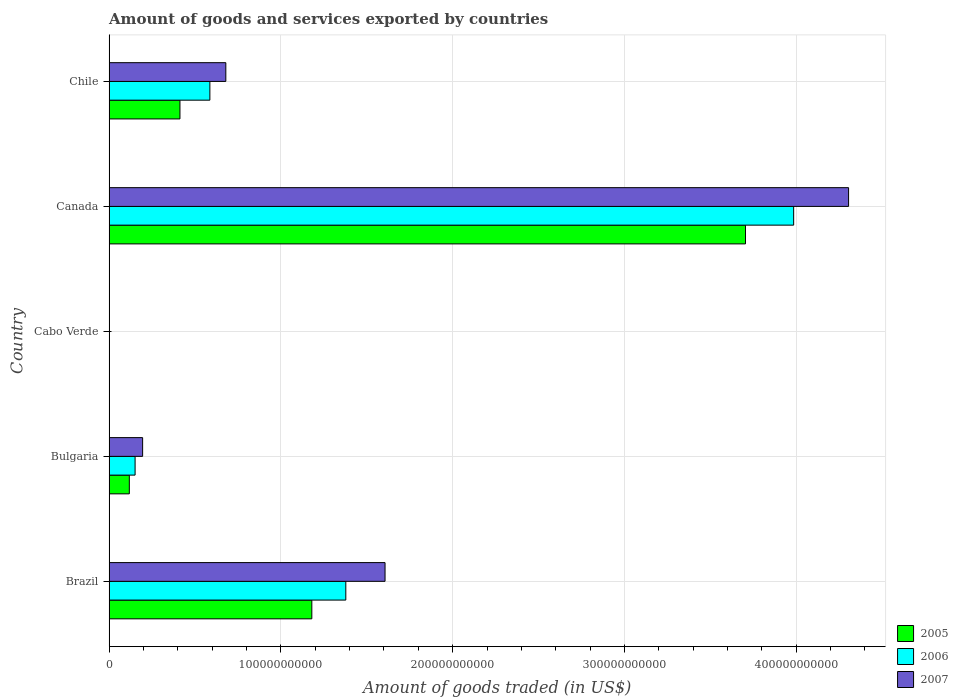How many different coloured bars are there?
Ensure brevity in your answer.  3. Are the number of bars per tick equal to the number of legend labels?
Offer a very short reply. Yes. How many bars are there on the 4th tick from the top?
Your answer should be compact. 3. How many bars are there on the 4th tick from the bottom?
Your answer should be very brief. 3. In how many cases, is the number of bars for a given country not equal to the number of legend labels?
Keep it short and to the point. 0. What is the total amount of goods and services exported in 2005 in Chile?
Keep it short and to the point. 4.13e+1. Across all countries, what is the maximum total amount of goods and services exported in 2007?
Ensure brevity in your answer.  4.30e+11. Across all countries, what is the minimum total amount of goods and services exported in 2005?
Provide a short and direct response. 7.71e+07. In which country was the total amount of goods and services exported in 2007 maximum?
Provide a short and direct response. Canada. In which country was the total amount of goods and services exported in 2006 minimum?
Provide a short and direct response. Cabo Verde. What is the total total amount of goods and services exported in 2005 in the graph?
Provide a succinct answer. 5.42e+11. What is the difference between the total amount of goods and services exported in 2006 in Bulgaria and that in Chile?
Make the answer very short. -4.35e+1. What is the difference between the total amount of goods and services exported in 2005 in Cabo Verde and the total amount of goods and services exported in 2007 in Chile?
Offer a terse response. -6.79e+1. What is the average total amount of goods and services exported in 2005 per country?
Provide a short and direct response. 1.08e+11. What is the difference between the total amount of goods and services exported in 2005 and total amount of goods and services exported in 2006 in Bulgaria?
Provide a succinct answer. -3.36e+09. What is the ratio of the total amount of goods and services exported in 2005 in Cabo Verde to that in Canada?
Your answer should be compact. 0. Is the total amount of goods and services exported in 2007 in Bulgaria less than that in Chile?
Make the answer very short. Yes. What is the difference between the highest and the second highest total amount of goods and services exported in 2006?
Provide a succinct answer. 2.61e+11. What is the difference between the highest and the lowest total amount of goods and services exported in 2006?
Provide a short and direct response. 3.98e+11. What does the 2nd bar from the top in Canada represents?
Your answer should be compact. 2006. Is it the case that in every country, the sum of the total amount of goods and services exported in 2007 and total amount of goods and services exported in 2005 is greater than the total amount of goods and services exported in 2006?
Provide a short and direct response. Yes. How many bars are there?
Offer a very short reply. 15. How many countries are there in the graph?
Your answer should be very brief. 5. What is the difference between two consecutive major ticks on the X-axis?
Provide a short and direct response. 1.00e+11. How are the legend labels stacked?
Provide a succinct answer. Vertical. What is the title of the graph?
Provide a short and direct response. Amount of goods and services exported by countries. What is the label or title of the X-axis?
Offer a very short reply. Amount of goods traded (in US$). What is the Amount of goods traded (in US$) in 2005 in Brazil?
Give a very brief answer. 1.18e+11. What is the Amount of goods traded (in US$) of 2006 in Brazil?
Keep it short and to the point. 1.38e+11. What is the Amount of goods traded (in US$) in 2007 in Brazil?
Your response must be concise. 1.61e+11. What is the Amount of goods traded (in US$) of 2005 in Bulgaria?
Offer a terse response. 1.18e+1. What is the Amount of goods traded (in US$) in 2006 in Bulgaria?
Your response must be concise. 1.52e+1. What is the Amount of goods traded (in US$) of 2007 in Bulgaria?
Keep it short and to the point. 1.95e+1. What is the Amount of goods traded (in US$) of 2005 in Cabo Verde?
Offer a very short reply. 7.71e+07. What is the Amount of goods traded (in US$) in 2006 in Cabo Verde?
Provide a short and direct response. 8.58e+07. What is the Amount of goods traded (in US$) in 2007 in Cabo Verde?
Offer a terse response. 6.97e+07. What is the Amount of goods traded (in US$) of 2005 in Canada?
Your response must be concise. 3.70e+11. What is the Amount of goods traded (in US$) in 2006 in Canada?
Your answer should be very brief. 3.99e+11. What is the Amount of goods traded (in US$) of 2007 in Canada?
Your answer should be very brief. 4.30e+11. What is the Amount of goods traded (in US$) of 2005 in Chile?
Give a very brief answer. 4.13e+1. What is the Amount of goods traded (in US$) in 2006 in Chile?
Give a very brief answer. 5.87e+1. What is the Amount of goods traded (in US$) of 2007 in Chile?
Provide a short and direct response. 6.80e+1. Across all countries, what is the maximum Amount of goods traded (in US$) in 2005?
Offer a terse response. 3.70e+11. Across all countries, what is the maximum Amount of goods traded (in US$) of 2006?
Provide a short and direct response. 3.99e+11. Across all countries, what is the maximum Amount of goods traded (in US$) of 2007?
Offer a very short reply. 4.30e+11. Across all countries, what is the minimum Amount of goods traded (in US$) of 2005?
Keep it short and to the point. 7.71e+07. Across all countries, what is the minimum Amount of goods traded (in US$) in 2006?
Offer a very short reply. 8.58e+07. Across all countries, what is the minimum Amount of goods traded (in US$) in 2007?
Keep it short and to the point. 6.97e+07. What is the total Amount of goods traded (in US$) of 2005 in the graph?
Make the answer very short. 5.42e+11. What is the total Amount of goods traded (in US$) of 2006 in the graph?
Provide a short and direct response. 6.10e+11. What is the total Amount of goods traded (in US$) in 2007 in the graph?
Make the answer very short. 6.79e+11. What is the difference between the Amount of goods traded (in US$) in 2005 in Brazil and that in Bulgaria?
Make the answer very short. 1.06e+11. What is the difference between the Amount of goods traded (in US$) in 2006 in Brazil and that in Bulgaria?
Provide a succinct answer. 1.23e+11. What is the difference between the Amount of goods traded (in US$) in 2007 in Brazil and that in Bulgaria?
Provide a short and direct response. 1.41e+11. What is the difference between the Amount of goods traded (in US$) in 2005 in Brazil and that in Cabo Verde?
Keep it short and to the point. 1.18e+11. What is the difference between the Amount of goods traded (in US$) of 2006 in Brazil and that in Cabo Verde?
Your answer should be compact. 1.38e+11. What is the difference between the Amount of goods traded (in US$) in 2007 in Brazil and that in Cabo Verde?
Keep it short and to the point. 1.61e+11. What is the difference between the Amount of goods traded (in US$) in 2005 in Brazil and that in Canada?
Your response must be concise. -2.52e+11. What is the difference between the Amount of goods traded (in US$) of 2006 in Brazil and that in Canada?
Provide a succinct answer. -2.61e+11. What is the difference between the Amount of goods traded (in US$) of 2007 in Brazil and that in Canada?
Provide a succinct answer. -2.70e+11. What is the difference between the Amount of goods traded (in US$) in 2005 in Brazil and that in Chile?
Provide a succinct answer. 7.68e+1. What is the difference between the Amount of goods traded (in US$) in 2006 in Brazil and that in Chile?
Your answer should be compact. 7.91e+1. What is the difference between the Amount of goods traded (in US$) in 2007 in Brazil and that in Chile?
Make the answer very short. 9.27e+1. What is the difference between the Amount of goods traded (in US$) in 2005 in Bulgaria and that in Cabo Verde?
Provide a short and direct response. 1.17e+1. What is the difference between the Amount of goods traded (in US$) of 2006 in Bulgaria and that in Cabo Verde?
Your answer should be compact. 1.51e+1. What is the difference between the Amount of goods traded (in US$) of 2007 in Bulgaria and that in Cabo Verde?
Give a very brief answer. 1.95e+1. What is the difference between the Amount of goods traded (in US$) in 2005 in Bulgaria and that in Canada?
Offer a very short reply. -3.59e+11. What is the difference between the Amount of goods traded (in US$) in 2006 in Bulgaria and that in Canada?
Provide a short and direct response. -3.83e+11. What is the difference between the Amount of goods traded (in US$) in 2007 in Bulgaria and that in Canada?
Offer a very short reply. -4.11e+11. What is the difference between the Amount of goods traded (in US$) of 2005 in Bulgaria and that in Chile?
Provide a short and direct response. -2.95e+1. What is the difference between the Amount of goods traded (in US$) in 2006 in Bulgaria and that in Chile?
Your answer should be compact. -4.35e+1. What is the difference between the Amount of goods traded (in US$) of 2007 in Bulgaria and that in Chile?
Give a very brief answer. -4.84e+1. What is the difference between the Amount of goods traded (in US$) in 2005 in Cabo Verde and that in Canada?
Keep it short and to the point. -3.70e+11. What is the difference between the Amount of goods traded (in US$) in 2006 in Cabo Verde and that in Canada?
Provide a short and direct response. -3.98e+11. What is the difference between the Amount of goods traded (in US$) in 2007 in Cabo Verde and that in Canada?
Provide a succinct answer. -4.30e+11. What is the difference between the Amount of goods traded (in US$) in 2005 in Cabo Verde and that in Chile?
Give a very brief answer. -4.12e+1. What is the difference between the Amount of goods traded (in US$) of 2006 in Cabo Verde and that in Chile?
Offer a terse response. -5.86e+1. What is the difference between the Amount of goods traded (in US$) in 2007 in Cabo Verde and that in Chile?
Make the answer very short. -6.79e+1. What is the difference between the Amount of goods traded (in US$) of 2005 in Canada and that in Chile?
Provide a succinct answer. 3.29e+11. What is the difference between the Amount of goods traded (in US$) of 2006 in Canada and that in Chile?
Your answer should be very brief. 3.40e+11. What is the difference between the Amount of goods traded (in US$) in 2007 in Canada and that in Chile?
Your answer should be compact. 3.63e+11. What is the difference between the Amount of goods traded (in US$) in 2005 in Brazil and the Amount of goods traded (in US$) in 2006 in Bulgaria?
Provide a short and direct response. 1.03e+11. What is the difference between the Amount of goods traded (in US$) of 2005 in Brazil and the Amount of goods traded (in US$) of 2007 in Bulgaria?
Keep it short and to the point. 9.85e+1. What is the difference between the Amount of goods traded (in US$) of 2006 in Brazil and the Amount of goods traded (in US$) of 2007 in Bulgaria?
Your response must be concise. 1.18e+11. What is the difference between the Amount of goods traded (in US$) in 2005 in Brazil and the Amount of goods traded (in US$) in 2006 in Cabo Verde?
Ensure brevity in your answer.  1.18e+11. What is the difference between the Amount of goods traded (in US$) of 2005 in Brazil and the Amount of goods traded (in US$) of 2007 in Cabo Verde?
Provide a short and direct response. 1.18e+11. What is the difference between the Amount of goods traded (in US$) in 2006 in Brazil and the Amount of goods traded (in US$) in 2007 in Cabo Verde?
Give a very brief answer. 1.38e+11. What is the difference between the Amount of goods traded (in US$) in 2005 in Brazil and the Amount of goods traded (in US$) in 2006 in Canada?
Give a very brief answer. -2.80e+11. What is the difference between the Amount of goods traded (in US$) in 2005 in Brazil and the Amount of goods traded (in US$) in 2007 in Canada?
Provide a succinct answer. -3.12e+11. What is the difference between the Amount of goods traded (in US$) in 2006 in Brazil and the Amount of goods traded (in US$) in 2007 in Canada?
Your answer should be very brief. -2.93e+11. What is the difference between the Amount of goods traded (in US$) of 2005 in Brazil and the Amount of goods traded (in US$) of 2006 in Chile?
Your response must be concise. 5.94e+1. What is the difference between the Amount of goods traded (in US$) of 2005 in Brazil and the Amount of goods traded (in US$) of 2007 in Chile?
Give a very brief answer. 5.01e+1. What is the difference between the Amount of goods traded (in US$) in 2006 in Brazil and the Amount of goods traded (in US$) in 2007 in Chile?
Offer a very short reply. 6.98e+1. What is the difference between the Amount of goods traded (in US$) of 2005 in Bulgaria and the Amount of goods traded (in US$) of 2006 in Cabo Verde?
Provide a short and direct response. 1.17e+1. What is the difference between the Amount of goods traded (in US$) of 2005 in Bulgaria and the Amount of goods traded (in US$) of 2007 in Cabo Verde?
Your answer should be compact. 1.17e+1. What is the difference between the Amount of goods traded (in US$) of 2006 in Bulgaria and the Amount of goods traded (in US$) of 2007 in Cabo Verde?
Provide a short and direct response. 1.51e+1. What is the difference between the Amount of goods traded (in US$) of 2005 in Bulgaria and the Amount of goods traded (in US$) of 2006 in Canada?
Your answer should be very brief. -3.87e+11. What is the difference between the Amount of goods traded (in US$) in 2005 in Bulgaria and the Amount of goods traded (in US$) in 2007 in Canada?
Keep it short and to the point. -4.19e+11. What is the difference between the Amount of goods traded (in US$) of 2006 in Bulgaria and the Amount of goods traded (in US$) of 2007 in Canada?
Keep it short and to the point. -4.15e+11. What is the difference between the Amount of goods traded (in US$) in 2005 in Bulgaria and the Amount of goods traded (in US$) in 2006 in Chile?
Give a very brief answer. -4.69e+1. What is the difference between the Amount of goods traded (in US$) of 2005 in Bulgaria and the Amount of goods traded (in US$) of 2007 in Chile?
Ensure brevity in your answer.  -5.62e+1. What is the difference between the Amount of goods traded (in US$) in 2006 in Bulgaria and the Amount of goods traded (in US$) in 2007 in Chile?
Your answer should be compact. -5.28e+1. What is the difference between the Amount of goods traded (in US$) of 2005 in Cabo Verde and the Amount of goods traded (in US$) of 2006 in Canada?
Your answer should be compact. -3.98e+11. What is the difference between the Amount of goods traded (in US$) of 2005 in Cabo Verde and the Amount of goods traded (in US$) of 2007 in Canada?
Ensure brevity in your answer.  -4.30e+11. What is the difference between the Amount of goods traded (in US$) in 2006 in Cabo Verde and the Amount of goods traded (in US$) in 2007 in Canada?
Offer a terse response. -4.30e+11. What is the difference between the Amount of goods traded (in US$) in 2005 in Cabo Verde and the Amount of goods traded (in US$) in 2006 in Chile?
Ensure brevity in your answer.  -5.86e+1. What is the difference between the Amount of goods traded (in US$) of 2005 in Cabo Verde and the Amount of goods traded (in US$) of 2007 in Chile?
Ensure brevity in your answer.  -6.79e+1. What is the difference between the Amount of goods traded (in US$) in 2006 in Cabo Verde and the Amount of goods traded (in US$) in 2007 in Chile?
Offer a very short reply. -6.79e+1. What is the difference between the Amount of goods traded (in US$) in 2005 in Canada and the Amount of goods traded (in US$) in 2006 in Chile?
Ensure brevity in your answer.  3.12e+11. What is the difference between the Amount of goods traded (in US$) of 2005 in Canada and the Amount of goods traded (in US$) of 2007 in Chile?
Give a very brief answer. 3.02e+11. What is the difference between the Amount of goods traded (in US$) of 2006 in Canada and the Amount of goods traded (in US$) of 2007 in Chile?
Your answer should be compact. 3.31e+11. What is the average Amount of goods traded (in US$) in 2005 per country?
Your answer should be compact. 1.08e+11. What is the average Amount of goods traded (in US$) in 2006 per country?
Your answer should be compact. 1.22e+11. What is the average Amount of goods traded (in US$) of 2007 per country?
Your answer should be very brief. 1.36e+11. What is the difference between the Amount of goods traded (in US$) of 2005 and Amount of goods traded (in US$) of 2006 in Brazil?
Offer a very short reply. -1.98e+1. What is the difference between the Amount of goods traded (in US$) in 2005 and Amount of goods traded (in US$) in 2007 in Brazil?
Provide a short and direct response. -4.26e+1. What is the difference between the Amount of goods traded (in US$) in 2006 and Amount of goods traded (in US$) in 2007 in Brazil?
Your response must be concise. -2.28e+1. What is the difference between the Amount of goods traded (in US$) of 2005 and Amount of goods traded (in US$) of 2006 in Bulgaria?
Ensure brevity in your answer.  -3.36e+09. What is the difference between the Amount of goods traded (in US$) in 2005 and Amount of goods traded (in US$) in 2007 in Bulgaria?
Make the answer very short. -7.74e+09. What is the difference between the Amount of goods traded (in US$) of 2006 and Amount of goods traded (in US$) of 2007 in Bulgaria?
Ensure brevity in your answer.  -4.38e+09. What is the difference between the Amount of goods traded (in US$) in 2005 and Amount of goods traded (in US$) in 2006 in Cabo Verde?
Give a very brief answer. -8.69e+06. What is the difference between the Amount of goods traded (in US$) in 2005 and Amount of goods traded (in US$) in 2007 in Cabo Verde?
Keep it short and to the point. 7.46e+06. What is the difference between the Amount of goods traded (in US$) in 2006 and Amount of goods traded (in US$) in 2007 in Cabo Verde?
Your answer should be very brief. 1.61e+07. What is the difference between the Amount of goods traded (in US$) of 2005 and Amount of goods traded (in US$) of 2006 in Canada?
Offer a terse response. -2.80e+1. What is the difference between the Amount of goods traded (in US$) in 2005 and Amount of goods traded (in US$) in 2007 in Canada?
Provide a succinct answer. -6.00e+1. What is the difference between the Amount of goods traded (in US$) in 2006 and Amount of goods traded (in US$) in 2007 in Canada?
Give a very brief answer. -3.20e+1. What is the difference between the Amount of goods traded (in US$) of 2005 and Amount of goods traded (in US$) of 2006 in Chile?
Make the answer very short. -1.74e+1. What is the difference between the Amount of goods traded (in US$) in 2005 and Amount of goods traded (in US$) in 2007 in Chile?
Keep it short and to the point. -2.67e+1. What is the difference between the Amount of goods traded (in US$) in 2006 and Amount of goods traded (in US$) in 2007 in Chile?
Keep it short and to the point. -9.29e+09. What is the ratio of the Amount of goods traded (in US$) of 2005 in Brazil to that in Bulgaria?
Offer a very short reply. 10.01. What is the ratio of the Amount of goods traded (in US$) in 2006 in Brazil to that in Bulgaria?
Provide a short and direct response. 9.09. What is the ratio of the Amount of goods traded (in US$) in 2007 in Brazil to that in Bulgaria?
Offer a very short reply. 8.22. What is the ratio of the Amount of goods traded (in US$) in 2005 in Brazil to that in Cabo Verde?
Make the answer very short. 1530.08. What is the ratio of the Amount of goods traded (in US$) in 2006 in Brazil to that in Cabo Verde?
Your answer should be compact. 1605.69. What is the ratio of the Amount of goods traded (in US$) in 2007 in Brazil to that in Cabo Verde?
Your answer should be compact. 2305.61. What is the ratio of the Amount of goods traded (in US$) in 2005 in Brazil to that in Canada?
Your answer should be compact. 0.32. What is the ratio of the Amount of goods traded (in US$) in 2006 in Brazil to that in Canada?
Keep it short and to the point. 0.35. What is the ratio of the Amount of goods traded (in US$) of 2007 in Brazil to that in Canada?
Provide a short and direct response. 0.37. What is the ratio of the Amount of goods traded (in US$) of 2005 in Brazil to that in Chile?
Give a very brief answer. 2.86. What is the ratio of the Amount of goods traded (in US$) in 2006 in Brazil to that in Chile?
Keep it short and to the point. 2.35. What is the ratio of the Amount of goods traded (in US$) of 2007 in Brazil to that in Chile?
Provide a succinct answer. 2.36. What is the ratio of the Amount of goods traded (in US$) of 2005 in Bulgaria to that in Cabo Verde?
Offer a very short reply. 152.85. What is the ratio of the Amount of goods traded (in US$) of 2006 in Bulgaria to that in Cabo Verde?
Offer a terse response. 176.57. What is the ratio of the Amount of goods traded (in US$) in 2007 in Bulgaria to that in Cabo Verde?
Your answer should be very brief. 280.34. What is the ratio of the Amount of goods traded (in US$) of 2005 in Bulgaria to that in Canada?
Make the answer very short. 0.03. What is the ratio of the Amount of goods traded (in US$) in 2006 in Bulgaria to that in Canada?
Your response must be concise. 0.04. What is the ratio of the Amount of goods traded (in US$) of 2007 in Bulgaria to that in Canada?
Provide a succinct answer. 0.05. What is the ratio of the Amount of goods traded (in US$) in 2005 in Bulgaria to that in Chile?
Your response must be concise. 0.29. What is the ratio of the Amount of goods traded (in US$) of 2006 in Bulgaria to that in Chile?
Keep it short and to the point. 0.26. What is the ratio of the Amount of goods traded (in US$) of 2007 in Bulgaria to that in Chile?
Your answer should be compact. 0.29. What is the ratio of the Amount of goods traded (in US$) in 2005 in Cabo Verde to that in Canada?
Make the answer very short. 0. What is the ratio of the Amount of goods traded (in US$) in 2006 in Cabo Verde to that in Canada?
Make the answer very short. 0. What is the ratio of the Amount of goods traded (in US$) of 2005 in Cabo Verde to that in Chile?
Give a very brief answer. 0. What is the ratio of the Amount of goods traded (in US$) in 2006 in Cabo Verde to that in Chile?
Keep it short and to the point. 0. What is the ratio of the Amount of goods traded (in US$) in 2005 in Canada to that in Chile?
Offer a terse response. 8.98. What is the ratio of the Amount of goods traded (in US$) of 2006 in Canada to that in Chile?
Provide a short and direct response. 6.79. What is the ratio of the Amount of goods traded (in US$) in 2007 in Canada to that in Chile?
Keep it short and to the point. 6.33. What is the difference between the highest and the second highest Amount of goods traded (in US$) in 2005?
Make the answer very short. 2.52e+11. What is the difference between the highest and the second highest Amount of goods traded (in US$) in 2006?
Keep it short and to the point. 2.61e+11. What is the difference between the highest and the second highest Amount of goods traded (in US$) in 2007?
Ensure brevity in your answer.  2.70e+11. What is the difference between the highest and the lowest Amount of goods traded (in US$) in 2005?
Your answer should be very brief. 3.70e+11. What is the difference between the highest and the lowest Amount of goods traded (in US$) in 2006?
Provide a short and direct response. 3.98e+11. What is the difference between the highest and the lowest Amount of goods traded (in US$) of 2007?
Your response must be concise. 4.30e+11. 